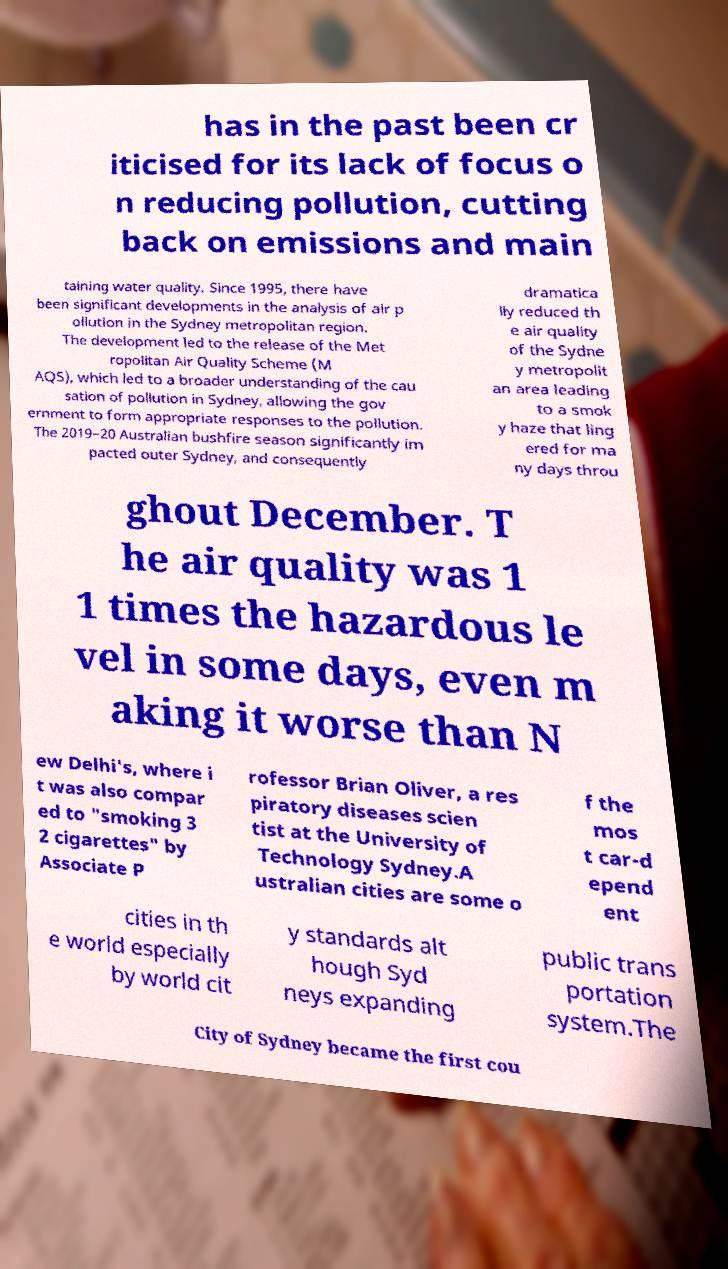I need the written content from this picture converted into text. Can you do that? has in the past been cr iticised for its lack of focus o n reducing pollution, cutting back on emissions and main taining water quality. Since 1995, there have been significant developments in the analysis of air p ollution in the Sydney metropolitan region. The development led to the release of the Met ropolitan Air Quality Scheme (M AQS), which led to a broader understanding of the cau sation of pollution in Sydney, allowing the gov ernment to form appropriate responses to the pollution. The 2019–20 Australian bushfire season significantly im pacted outer Sydney, and consequently dramatica lly reduced th e air quality of the Sydne y metropolit an area leading to a smok y haze that ling ered for ma ny days throu ghout December. T he air quality was 1 1 times the hazardous le vel in some days, even m aking it worse than N ew Delhi's, where i t was also compar ed to "smoking 3 2 cigarettes" by Associate P rofessor Brian Oliver, a res piratory diseases scien tist at the University of Technology Sydney.A ustralian cities are some o f the mos t car-d epend ent cities in th e world especially by world cit y standards alt hough Syd neys expanding public trans portation system.The City of Sydney became the first cou 